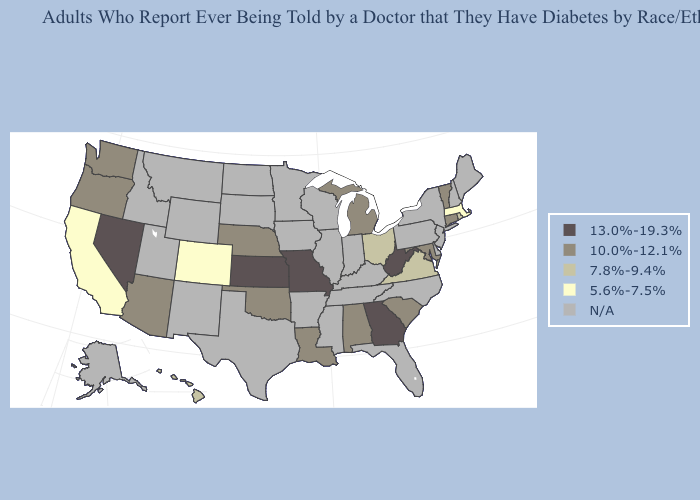What is the lowest value in the West?
Quick response, please. 5.6%-7.5%. Does Hawaii have the highest value in the USA?
Short answer required. No. Name the states that have a value in the range 7.8%-9.4%?
Answer briefly. Hawaii, Ohio, Rhode Island, Virginia. Does the first symbol in the legend represent the smallest category?
Be succinct. No. Among the states that border Michigan , which have the lowest value?
Write a very short answer. Ohio. Which states hav the highest value in the South?
Be succinct. Georgia, West Virginia. Does Massachusetts have the lowest value in the USA?
Give a very brief answer. Yes. What is the lowest value in the USA?
Keep it brief. 5.6%-7.5%. Is the legend a continuous bar?
Quick response, please. No. How many symbols are there in the legend?
Quick response, please. 5. What is the highest value in states that border New York?
Keep it brief. 10.0%-12.1%. What is the lowest value in states that border Georgia?
Quick response, please. 10.0%-12.1%. How many symbols are there in the legend?
Keep it brief. 5. What is the value of Illinois?
Write a very short answer. N/A. 